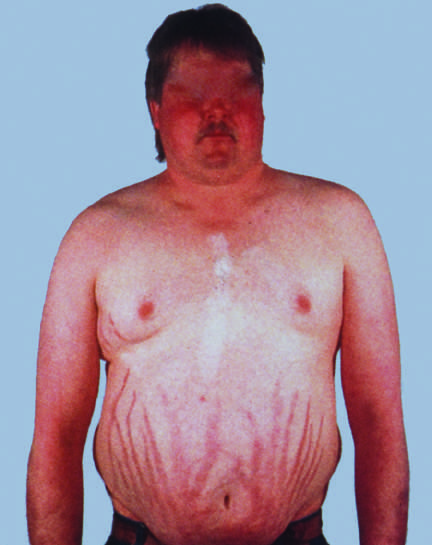do characteristic features include central obesity, moon facies, and abdominal striae?
Answer the question using a single word or phrase. Yes 